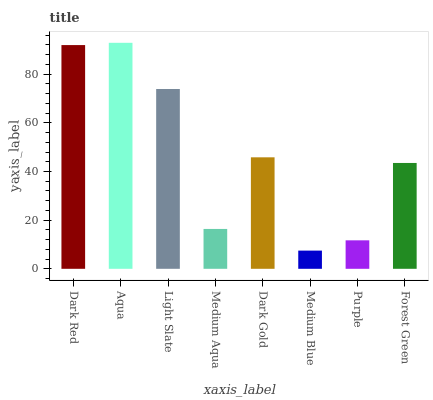Is Medium Blue the minimum?
Answer yes or no. Yes. Is Aqua the maximum?
Answer yes or no. Yes. Is Light Slate the minimum?
Answer yes or no. No. Is Light Slate the maximum?
Answer yes or no. No. Is Aqua greater than Light Slate?
Answer yes or no. Yes. Is Light Slate less than Aqua?
Answer yes or no. Yes. Is Light Slate greater than Aqua?
Answer yes or no. No. Is Aqua less than Light Slate?
Answer yes or no. No. Is Dark Gold the high median?
Answer yes or no. Yes. Is Forest Green the low median?
Answer yes or no. Yes. Is Medium Blue the high median?
Answer yes or no. No. Is Aqua the low median?
Answer yes or no. No. 